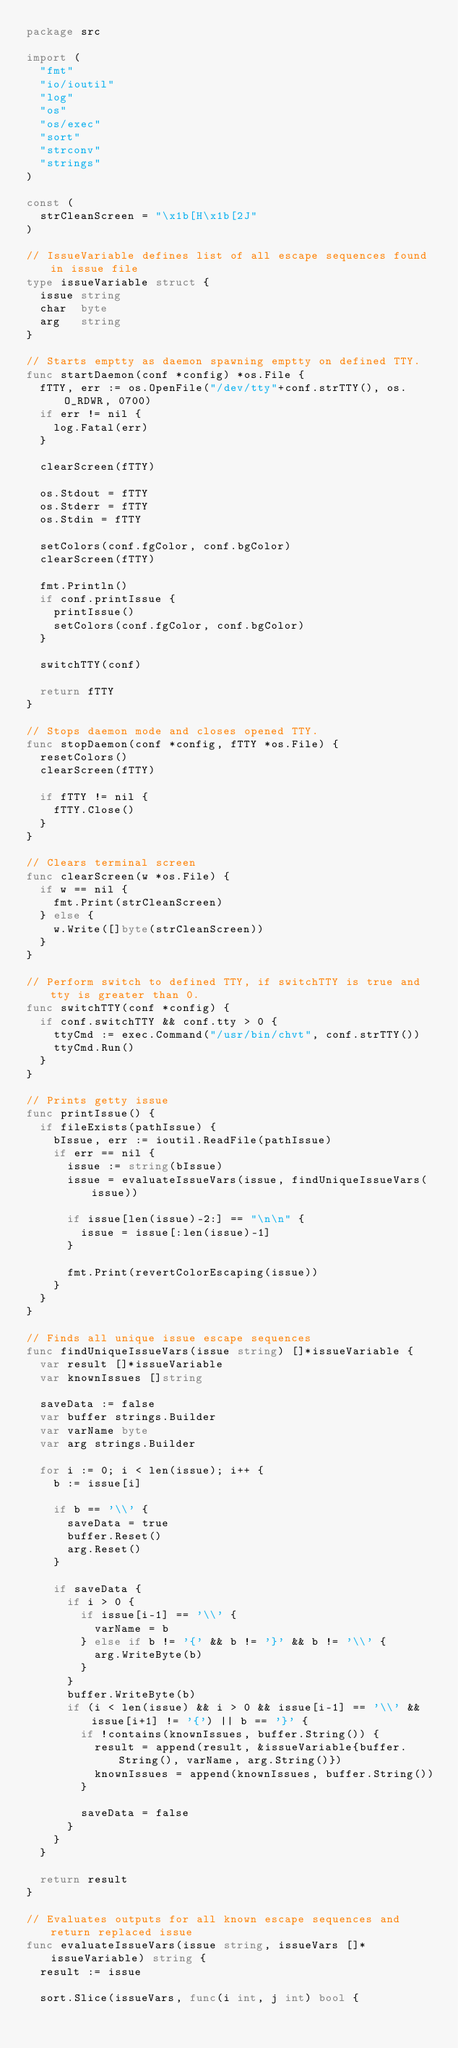<code> <loc_0><loc_0><loc_500><loc_500><_Go_>package src

import (
	"fmt"
	"io/ioutil"
	"log"
	"os"
	"os/exec"
	"sort"
	"strconv"
	"strings"
)

const (
	strCleanScreen = "\x1b[H\x1b[2J"
)

// IssueVariable defines list of all escape sequences found in issue file
type issueVariable struct {
	issue string
	char  byte
	arg   string
}

// Starts emptty as daemon spawning emptty on defined TTY.
func startDaemon(conf *config) *os.File {
	fTTY, err := os.OpenFile("/dev/tty"+conf.strTTY(), os.O_RDWR, 0700)
	if err != nil {
		log.Fatal(err)
	}

	clearScreen(fTTY)

	os.Stdout = fTTY
	os.Stderr = fTTY
	os.Stdin = fTTY

	setColors(conf.fgColor, conf.bgColor)
	clearScreen(fTTY)

	fmt.Println()
	if conf.printIssue {
		printIssue()
		setColors(conf.fgColor, conf.bgColor)
	}

	switchTTY(conf)

	return fTTY
}

// Stops daemon mode and closes opened TTY.
func stopDaemon(conf *config, fTTY *os.File) {
	resetColors()
	clearScreen(fTTY)

	if fTTY != nil {
		fTTY.Close()
	}
}

// Clears terminal screen
func clearScreen(w *os.File) {
	if w == nil {
		fmt.Print(strCleanScreen)
	} else {
		w.Write([]byte(strCleanScreen))
	}
}

// Perform switch to defined TTY, if switchTTY is true and tty is greater than 0.
func switchTTY(conf *config) {
	if conf.switchTTY && conf.tty > 0 {
		ttyCmd := exec.Command("/usr/bin/chvt", conf.strTTY())
		ttyCmd.Run()
	}
}

// Prints getty issue
func printIssue() {
	if fileExists(pathIssue) {
		bIssue, err := ioutil.ReadFile(pathIssue)
		if err == nil {
			issue := string(bIssue)
			issue = evaluateIssueVars(issue, findUniqueIssueVars(issue))

			if issue[len(issue)-2:] == "\n\n" {
				issue = issue[:len(issue)-1]
			}

			fmt.Print(revertColorEscaping(issue))
		}
	}
}

// Finds all unique issue escape sequences
func findUniqueIssueVars(issue string) []*issueVariable {
	var result []*issueVariable
	var knownIssues []string

	saveData := false
	var buffer strings.Builder
	var varName byte
	var arg strings.Builder

	for i := 0; i < len(issue); i++ {
		b := issue[i]

		if b == '\\' {
			saveData = true
			buffer.Reset()
			arg.Reset()
		}

		if saveData {
			if i > 0 {
				if issue[i-1] == '\\' {
					varName = b
				} else if b != '{' && b != '}' && b != '\\' {
					arg.WriteByte(b)
				}
			}
			buffer.WriteByte(b)
			if (i < len(issue) && i > 0 && issue[i-1] == '\\' && issue[i+1] != '{') || b == '}' {
				if !contains(knownIssues, buffer.String()) {
					result = append(result, &issueVariable{buffer.String(), varName, arg.String()})
					knownIssues = append(knownIssues, buffer.String())
				}

				saveData = false
			}
		}
	}

	return result
}

// Evaluates outputs for all known escape sequences and return replaced issue
func evaluateIssueVars(issue string, issueVars []*issueVariable) string {
	result := issue

	sort.Slice(issueVars, func(i int, j int) bool {</code> 